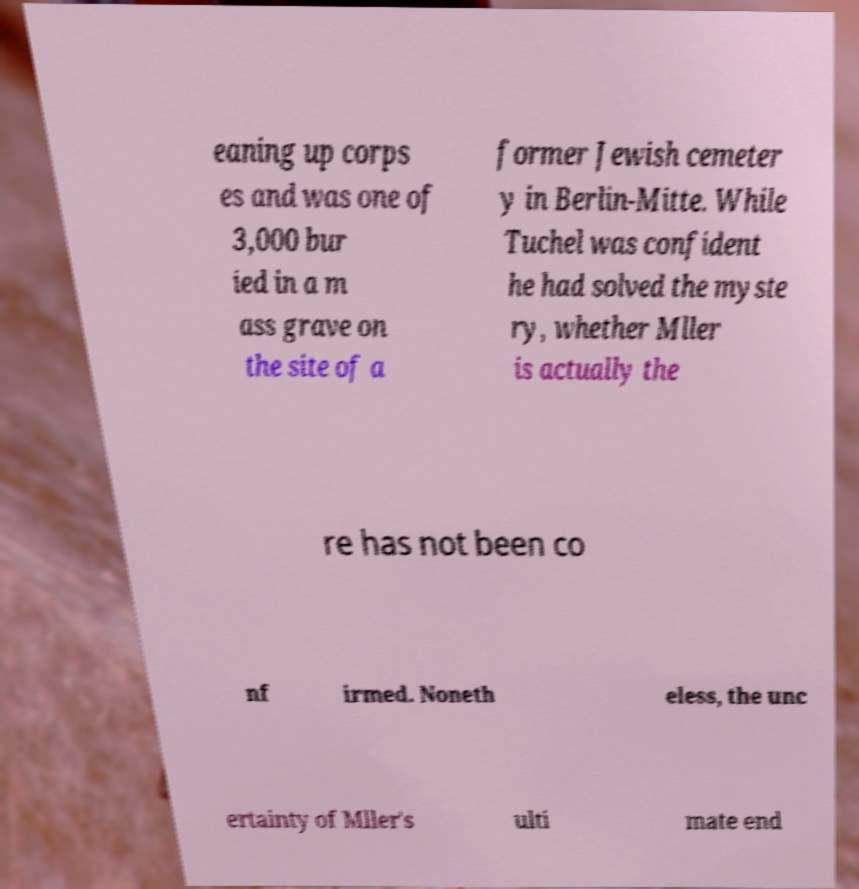I need the written content from this picture converted into text. Can you do that? eaning up corps es and was one of 3,000 bur ied in a m ass grave on the site of a former Jewish cemeter y in Berlin-Mitte. While Tuchel was confident he had solved the myste ry, whether Mller is actually the re has not been co nf irmed. Noneth eless, the unc ertainty of Mller's ulti mate end 